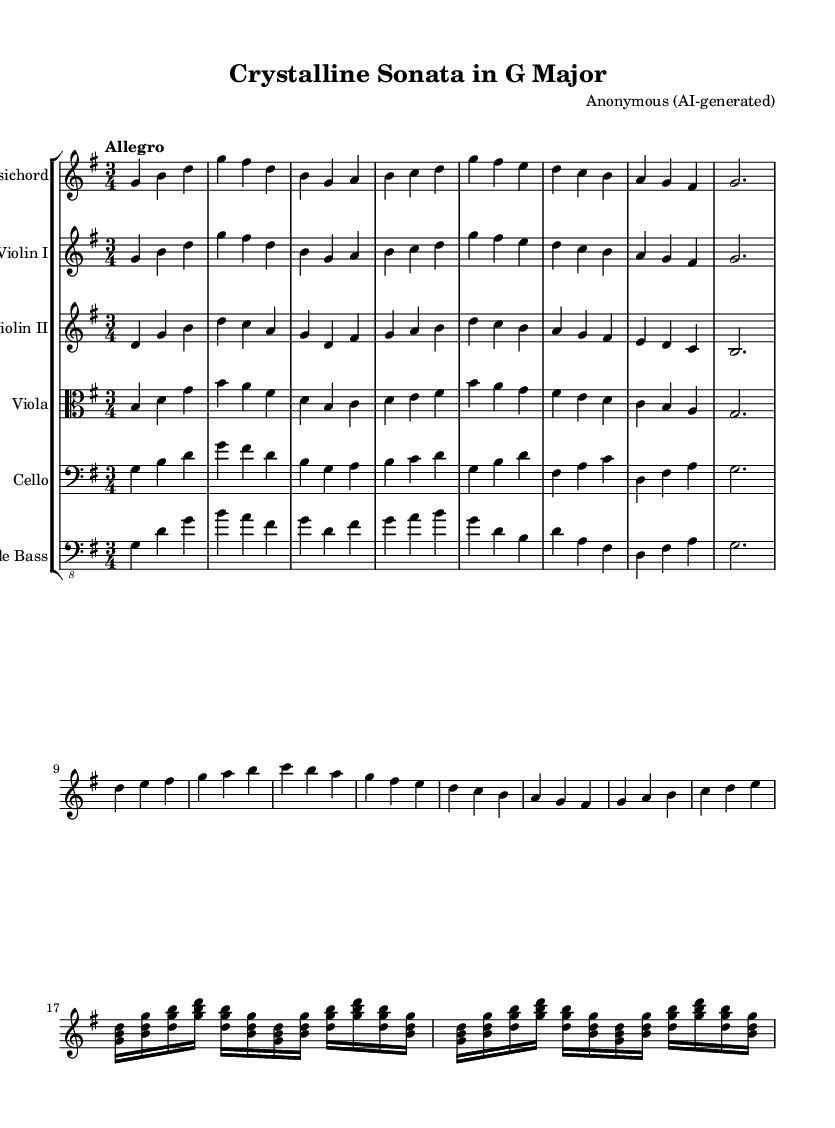What is the title of this piece? The title is prominently displayed in the header section at the top of the sheet music. It says "Crystalline Sonata in G Major."
Answer: Crystalline Sonata in G Major What is the key signature of this music? The key signature is indicated by the sharp indicated in the sheet music. Here, it is G major, which has one sharp.
Answer: G major What is the time signature of this music? The time signature appears at the beginning of the piece and is shown as 3/4, which means there are three beats per measure.
Answer: 3/4 What is the tempo marking for this piece? The tempo marking is written in Italian, which is a common practice in classical music. Here, it is marked "Allegro," indicating a fast and lively tempo.
Answer: Allegro Which instruments are included in the score? The instruments are listed within the staff group notation. The visible instruments in this score are Harpsichord, Violin I, Violin II, Viola, Cello, and Double Bass.
Answer: Harpsichord, Violin I, Violin II, Viola, Cello, Double Bass How many measures are in the first section of the harpsichord part? By counting the number of vertical lines (bar lines) in the harpsichord part, we can determine the number of measures. The first section contains 8 measures before the break.
Answer: 8 What characteristic of Baroque music is demonstrated by the use of orchestration in this piece? Baroque music often employs a mix of instruments and contrasts different groups, demonstrated here by the combination of string instruments with the harpsichord. This approach accentuates texture and harmony, typical of the Baroque style.
Answer: Orchestration 